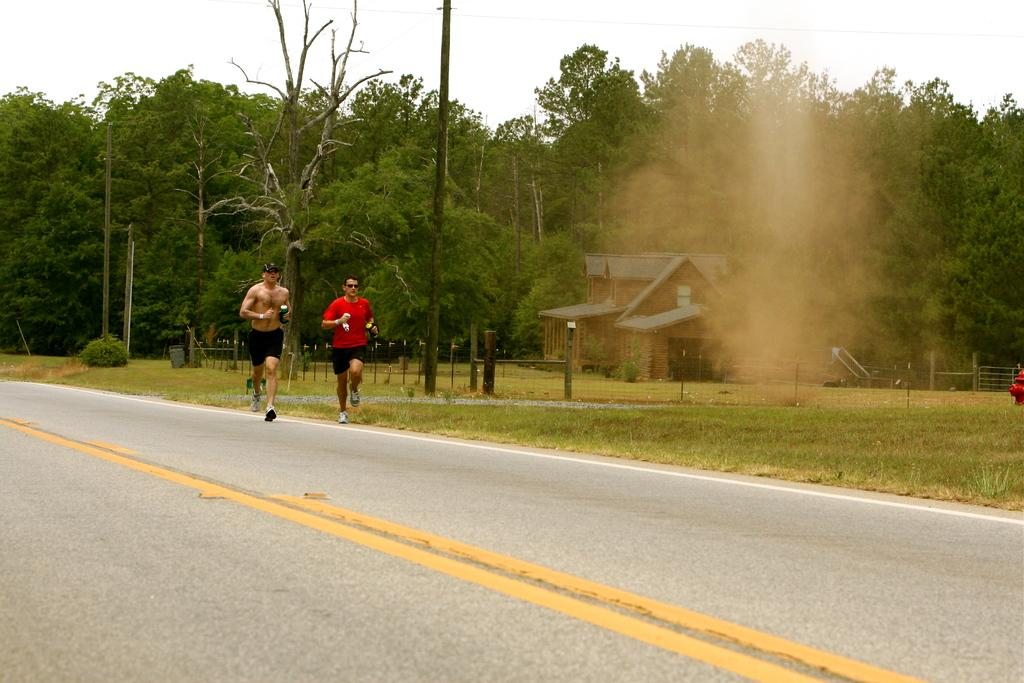What are the two people in the image doing? The two people in the image are running. On what surface are they running? They are running on a road. What can be seen in the background of the image? There are trees, a house, a fence, poles, grass, and the sky visible in the background of the image. What type of kite is being flown by one of the runners in the image? There is no kite present in the image; the two people are running without any kites. How many nails can be seen in the image? There are no nails visible in the image. 